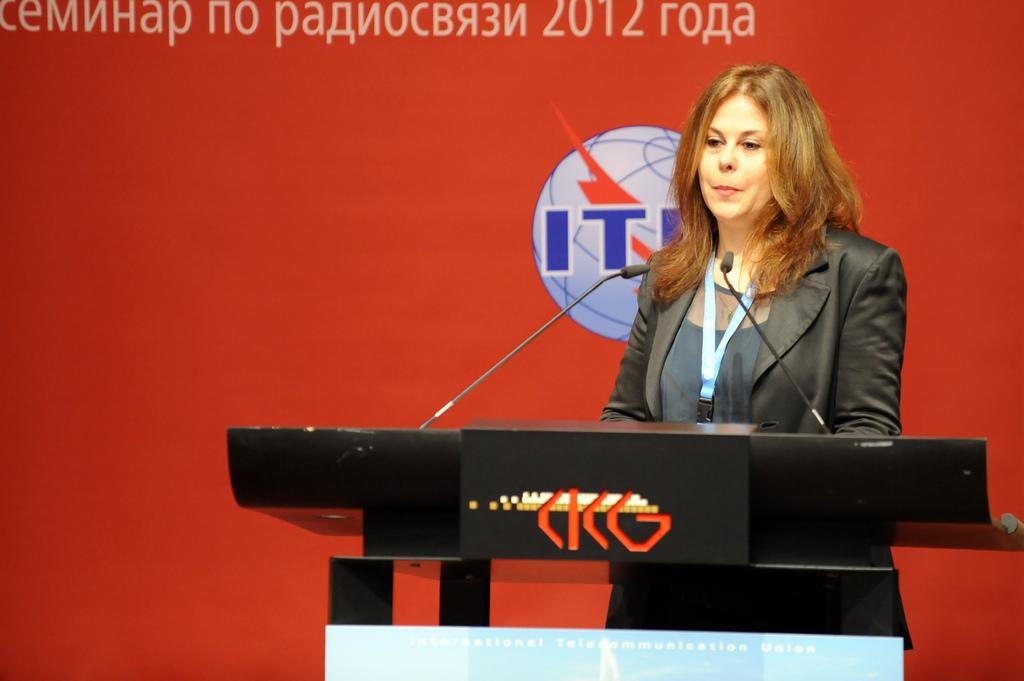In one or two sentences, can you explain what this image depicts? In this image we can see a lady standing behind a podium and there is a logo, some text and two microphones on it, behind her there is poster which contains some text and a logo. 